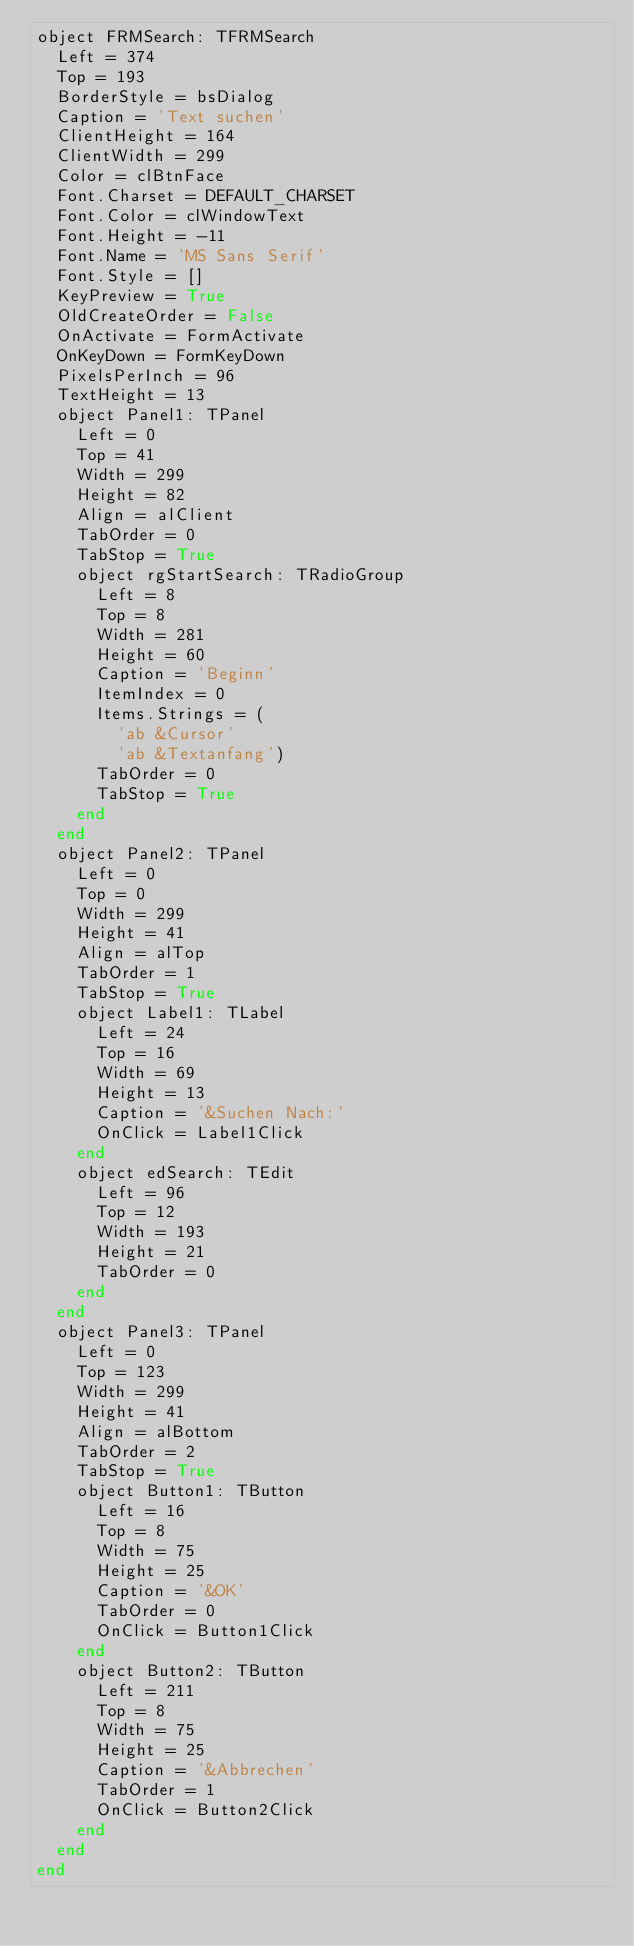Convert code to text. <code><loc_0><loc_0><loc_500><loc_500><_Pascal_>object FRMSearch: TFRMSearch
  Left = 374
  Top = 193
  BorderStyle = bsDialog
  Caption = 'Text suchen'
  ClientHeight = 164
  ClientWidth = 299
  Color = clBtnFace
  Font.Charset = DEFAULT_CHARSET
  Font.Color = clWindowText
  Font.Height = -11
  Font.Name = 'MS Sans Serif'
  Font.Style = []
  KeyPreview = True
  OldCreateOrder = False
  OnActivate = FormActivate
  OnKeyDown = FormKeyDown
  PixelsPerInch = 96
  TextHeight = 13
  object Panel1: TPanel
    Left = 0
    Top = 41
    Width = 299
    Height = 82
    Align = alClient
    TabOrder = 0
    TabStop = True
    object rgStartSearch: TRadioGroup
      Left = 8
      Top = 8
      Width = 281
      Height = 60
      Caption = 'Beginn'
      ItemIndex = 0
      Items.Strings = (
        'ab &Cursor'
        'ab &Textanfang')
      TabOrder = 0
      TabStop = True
    end
  end
  object Panel2: TPanel
    Left = 0
    Top = 0
    Width = 299
    Height = 41
    Align = alTop
    TabOrder = 1
    TabStop = True
    object Label1: TLabel
      Left = 24
      Top = 16
      Width = 69
      Height = 13
      Caption = '&Suchen Nach:'
      OnClick = Label1Click
    end
    object edSearch: TEdit
      Left = 96
      Top = 12
      Width = 193
      Height = 21
      TabOrder = 0
    end
  end
  object Panel3: TPanel
    Left = 0
    Top = 123
    Width = 299
    Height = 41
    Align = alBottom
    TabOrder = 2
    TabStop = True
    object Button1: TButton
      Left = 16
      Top = 8
      Width = 75
      Height = 25
      Caption = '&OK'
      TabOrder = 0
      OnClick = Button1Click
    end
    object Button2: TButton
      Left = 211
      Top = 8
      Width = 75
      Height = 25
      Caption = '&Abbrechen'
      TabOrder = 1
      OnClick = Button2Click
    end
  end
end
</code> 